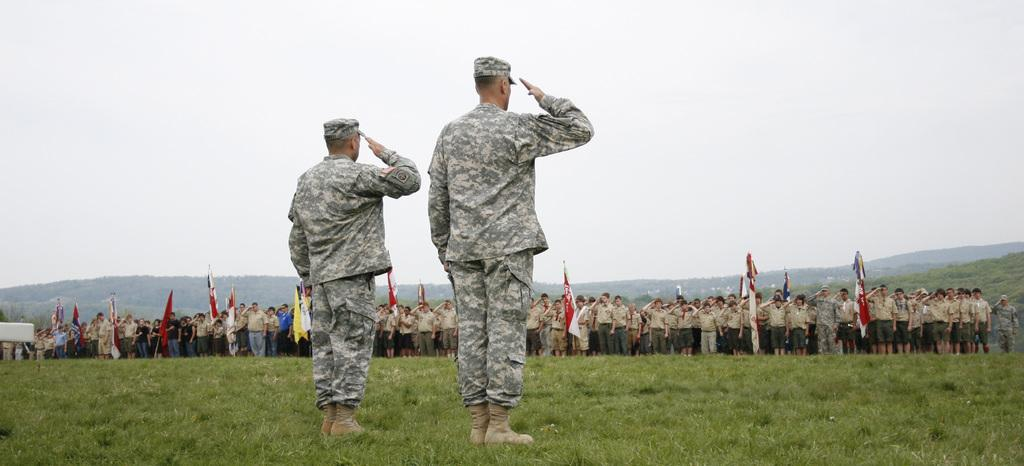What are the people in the image doing? The people in the image are in salute position. What else can be seen in the image besides the people? There are flags and a mountain in the background of the image. What type of vegetation is present in the background of the image? There is a ground full of grass in the background of the image. What type of shoes are the people wearing in the image? There is no information about shoes in the image, as the focus is on the people in salute position and the flags. --- 